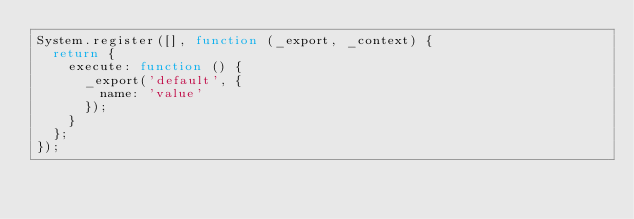<code> <loc_0><loc_0><loc_500><loc_500><_JavaScript_>System.register([], function (_export, _context) {
  return {
    execute: function () {
      _export('default', {
        name: 'value'
      });
    }
  };
});</code> 